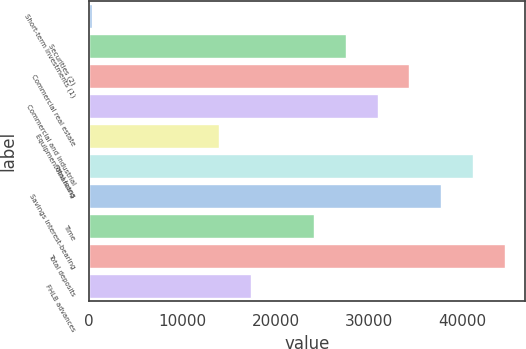Convert chart. <chart><loc_0><loc_0><loc_500><loc_500><bar_chart><fcel>Short-term investments (1)<fcel>Securities (2)<fcel>Commercial real estate<fcel>Commercial and industrial<fcel>Equipment financing<fcel>Total loans<fcel>Savings interest-bearing<fcel>Time<fcel>Total deposits<fcel>FHLB advances<nl><fcel>328.7<fcel>27509.7<fcel>34305<fcel>30907.4<fcel>13919.2<fcel>41100.3<fcel>37702.6<fcel>24112.1<fcel>44497.9<fcel>17316.8<nl></chart> 